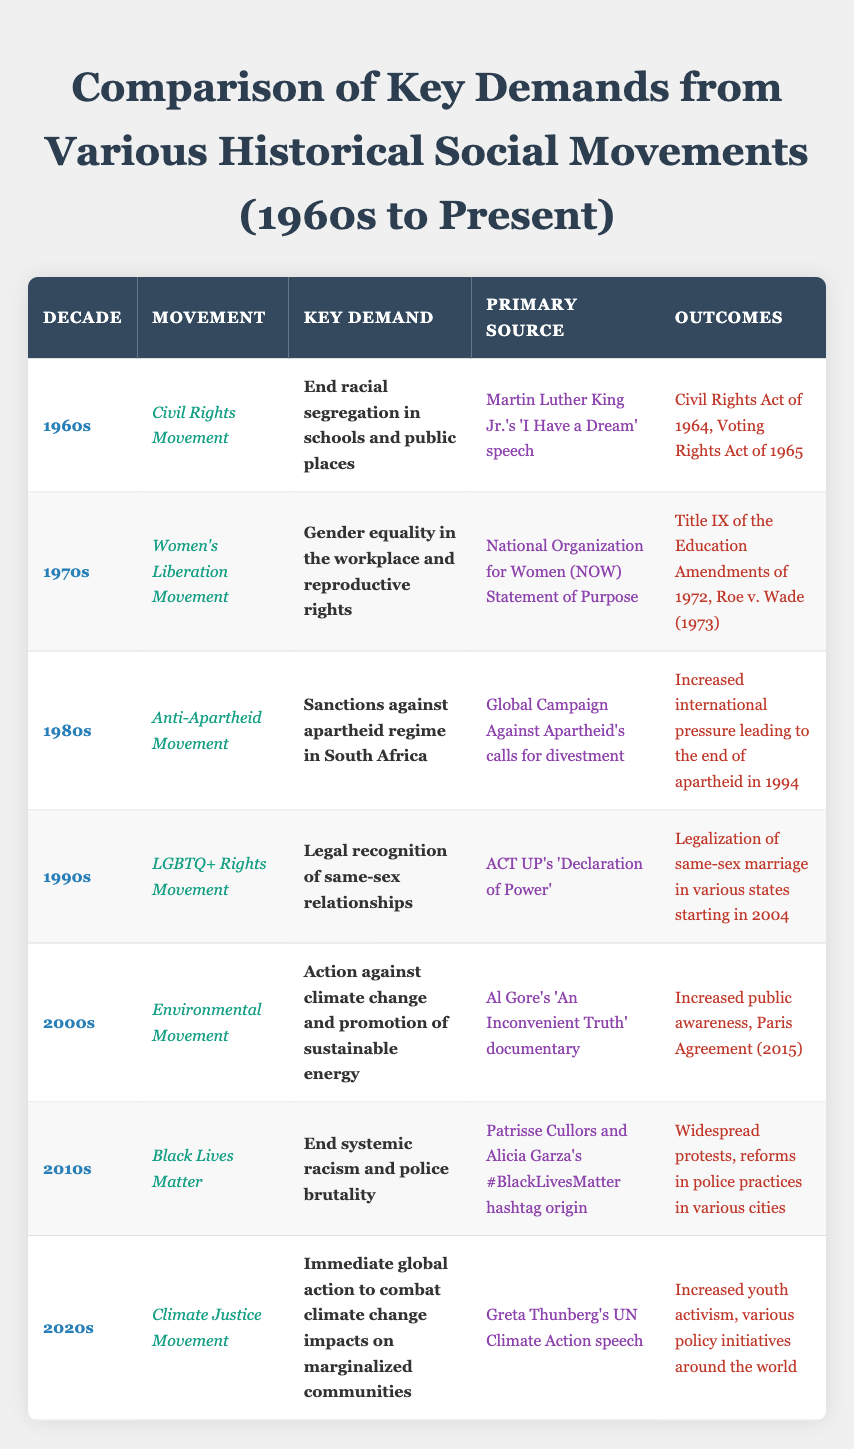What was the key demand of the Women's Liberation Movement in the 1970s? The table specifies that the key demand of the Women's Liberation Movement in the 1970s was "Gender equality in the workplace and reproductive rights."
Answer: Gender equality in the workplace and reproductive rights Which primary source is associated with the Civil Rights Movement? According to the table, the primary source associated with the Civil Rights Movement is "Martin Luther King Jr.'s 'I Have a Dream' speech."
Answer: Martin Luther King Jr.'s 'I Have a Dream' speech How many movements are listed in the table? There are 7 movements listed in the table, which are Civil Rights Movement, Women's Liberation Movement, Anti-Apartheid Movement, LGBTQ+ Rights Movement, Environmental Movement, Black Lives Matter, and Climate Justice Movement.
Answer: 7 What outcomes were achieved by the LGBTQ+ Rights Movement? The table indicates that the outcomes achieved by the LGBTQ+ Rights Movement include "Legalization of same-sex marriage in various states starting in 2004."
Answer: Legalization of same-sex marriage in various states starting in 2004 Is the key demand of the Anti-Apartheid Movement related to environmental issues? The key demand is specified as "Sanctions against apartheid regime in South Africa," which is not related to environmental issues, thus the answer is no.
Answer: No Which decade saw the formulation of key demands for both women and environmental issues? The 1970s saw the Women's Liberation Movement, while the 2000s focused on the Environmental Movement. Therefore, they were in different decades.
Answer: No common decade List the movements that achieved legal reforms and their corresponding outcomes. The movements that achieved legal reforms include the Women's Liberation Movement with outcomes of "Title IX of the Education Amendments of 1972, Roe v. Wade (1973)," and the LGBTQ+ Rights Movement with "Legalization of same-sex marriage in various states starting in 2004."
Answer: Women's Liberation Movement and LGBTQ+ Rights Movement Which movement's primary source highlights youth activism? The Climate Justice Movement cites "Greta Thunberg's UN Climate Action speech," which emphasizes youth activism as a crucial aspect of their advocacy.
Answer: Climate Justice Movement What is the relationship between the outcomes of the Civil Rights Movement and the subsequent social movements in the table? The outcomes of the Civil Rights Movement in the 1960s, such as the Civil Rights Act of 1964 and the Voting Rights Act of 1965, laid the groundwork for later social movements by addressing racial equality and influencing the framework for protests and demands in subsequent decades.
Answer: Foundational influence Were the demands of the Anti-Apartheid Movement and the Climate Justice Movement focused on the same issues? The Anti-Apartheid Movement's demand was regarding sanctions against the apartheid regime, while the Climate Justice Movement focused on combating climate change, thus highlighting different issues.
Answer: No, they focused on different issues 